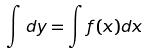Convert formula to latex. <formula><loc_0><loc_0><loc_500><loc_500>\int d y = \int f ( x ) d x</formula> 